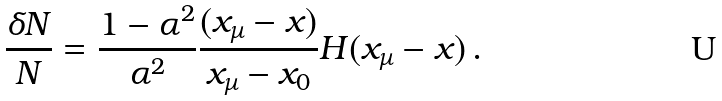Convert formula to latex. <formula><loc_0><loc_0><loc_500><loc_500>\frac { \delta N } { N } = \frac { 1 - \alpha ^ { 2 } } { \alpha ^ { 2 } } \frac { ( x _ { \mu } - x ) } { x _ { \mu } - x _ { 0 } } H ( x _ { \mu } - x ) \, .</formula> 